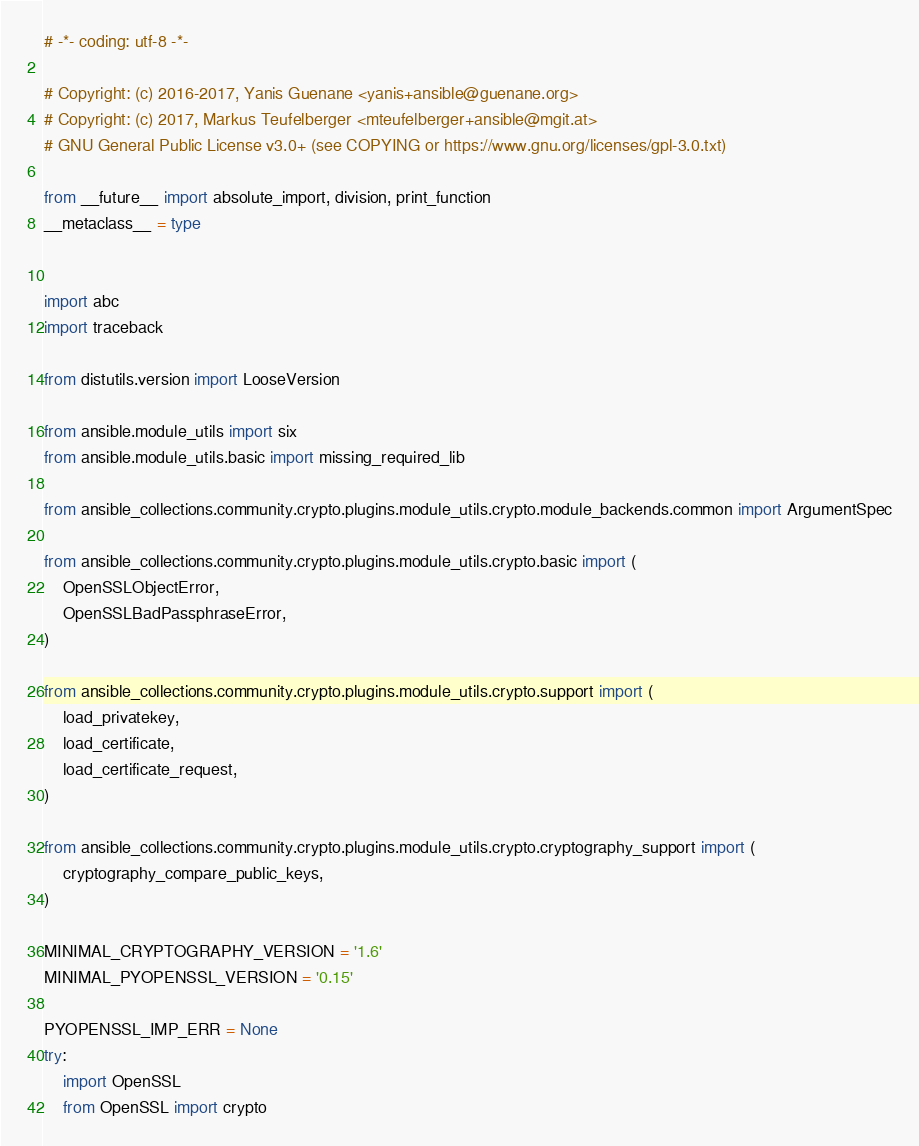Convert code to text. <code><loc_0><loc_0><loc_500><loc_500><_Python_># -*- coding: utf-8 -*-

# Copyright: (c) 2016-2017, Yanis Guenane <yanis+ansible@guenane.org>
# Copyright: (c) 2017, Markus Teufelberger <mteufelberger+ansible@mgit.at>
# GNU General Public License v3.0+ (see COPYING or https://www.gnu.org/licenses/gpl-3.0.txt)

from __future__ import absolute_import, division, print_function
__metaclass__ = type


import abc
import traceback

from distutils.version import LooseVersion

from ansible.module_utils import six
from ansible.module_utils.basic import missing_required_lib

from ansible_collections.community.crypto.plugins.module_utils.crypto.module_backends.common import ArgumentSpec

from ansible_collections.community.crypto.plugins.module_utils.crypto.basic import (
    OpenSSLObjectError,
    OpenSSLBadPassphraseError,
)

from ansible_collections.community.crypto.plugins.module_utils.crypto.support import (
    load_privatekey,
    load_certificate,
    load_certificate_request,
)

from ansible_collections.community.crypto.plugins.module_utils.crypto.cryptography_support import (
    cryptography_compare_public_keys,
)

MINIMAL_CRYPTOGRAPHY_VERSION = '1.6'
MINIMAL_PYOPENSSL_VERSION = '0.15'

PYOPENSSL_IMP_ERR = None
try:
    import OpenSSL
    from OpenSSL import crypto</code> 